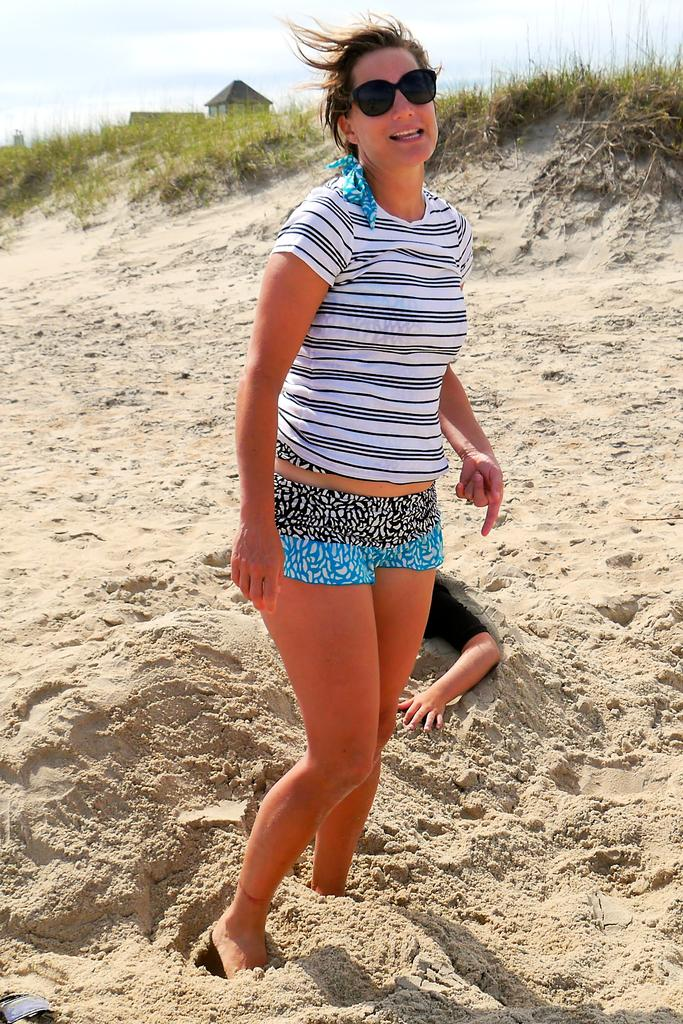What is the main subject in the middle of the image? There is a lady standing in the middle of the image. What is the lady wearing on her face? The lady is wearing sunglasses. Can you describe the person in the sand? There is another person in the sand, but their appearance or actions are not specified. What can be seen in the background of the image? There is a building and grassland in the background of the image. What type of throne can be seen in the image? There is no throne present in the image. Can you hear the lady's voice in the image? The image is a still picture, so it does not contain any sound or voice. 